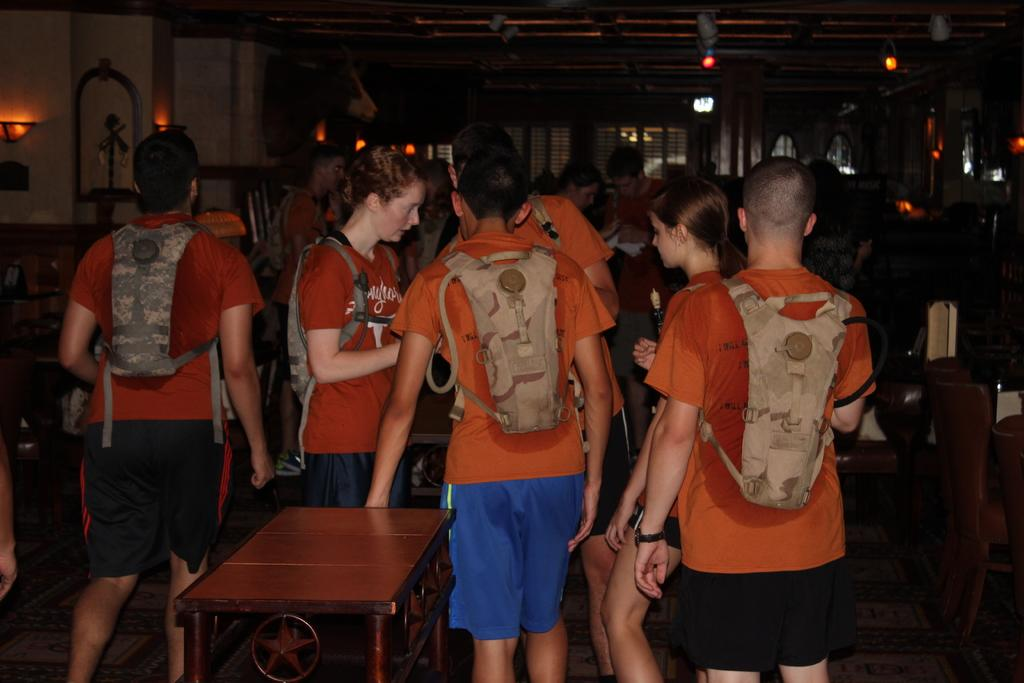How many people are in the image? There is a group of people in the image. What are the people wearing? The people are wearing orange t-shirts and blue shorts. What are the people carrying? The people are carrying bags. What furniture is present in the room? There are tables and chairs in the room. How would you describe the lighting in the room? The room appears to be a little dark. What type of fear can be seen on the people's faces in the image? There is no indication of fear on the people's faces in the image. What direction are the people standing in line in the image? There is no line present in the image; the people are simply standing in a group. 